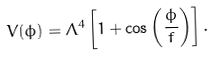Convert formula to latex. <formula><loc_0><loc_0><loc_500><loc_500>V ( \phi ) = \Lambda ^ { 4 } \left [ 1 + \cos \left ( \frac { \phi } { f } \right ) \right ] .</formula> 